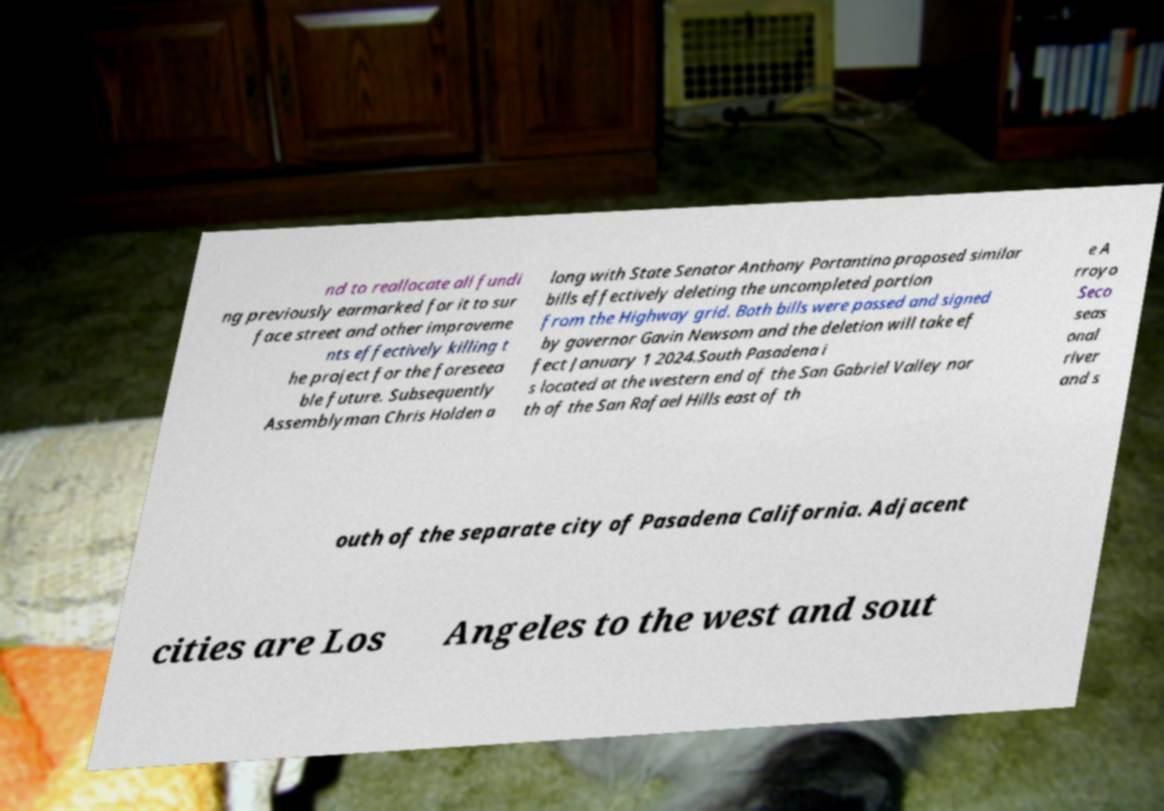I need the written content from this picture converted into text. Can you do that? nd to reallocate all fundi ng previously earmarked for it to sur face street and other improveme nts effectively killing t he project for the foreseea ble future. Subsequently Assemblyman Chris Holden a long with State Senator Anthony Portantino proposed similar bills effectively deleting the uncompleted portion from the Highway grid. Both bills were passed and signed by governor Gavin Newsom and the deletion will take ef fect January 1 2024.South Pasadena i s located at the western end of the San Gabriel Valley nor th of the San Rafael Hills east of th e A rroyo Seco seas onal river and s outh of the separate city of Pasadena California. Adjacent cities are Los Angeles to the west and sout 